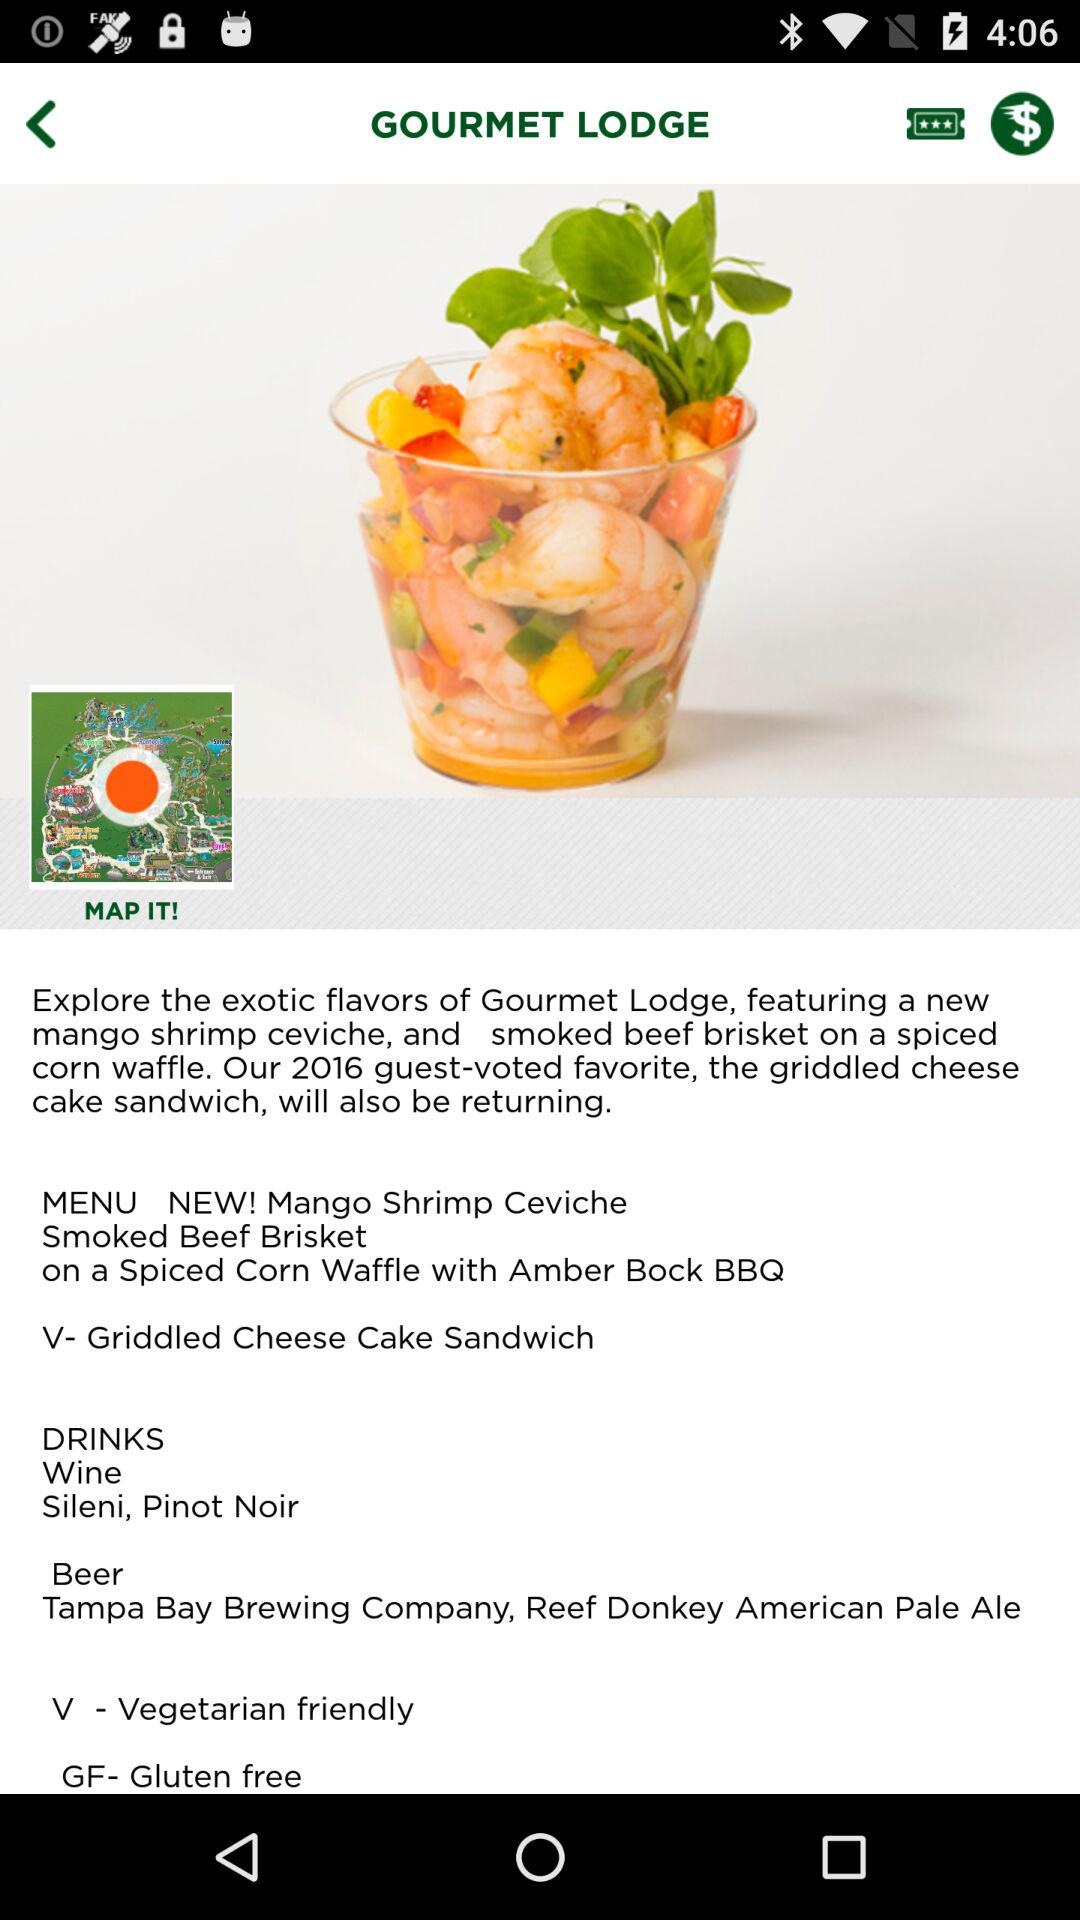How many items in the MENU section are vegetarian friendly?
Answer the question using a single word or phrase. 1 